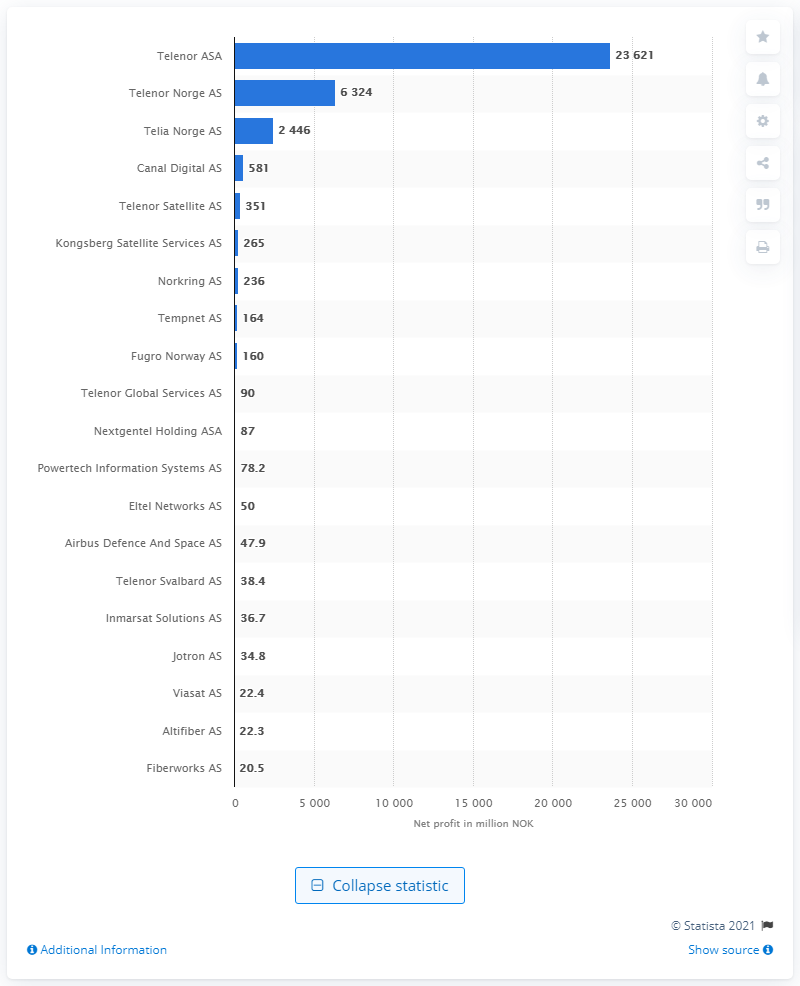List a handful of essential elements in this visual. Telenor ASA's net profit was 23,621. As of August 2020, the profit of Telenor Norge AS was 6,324. Telenor Norge AS was ranked as the second most profitable telecommunication company in Norway as of August 2020, according to the ranking of the 20 most profitable telecommunication companies in Norway as of August 2020. 